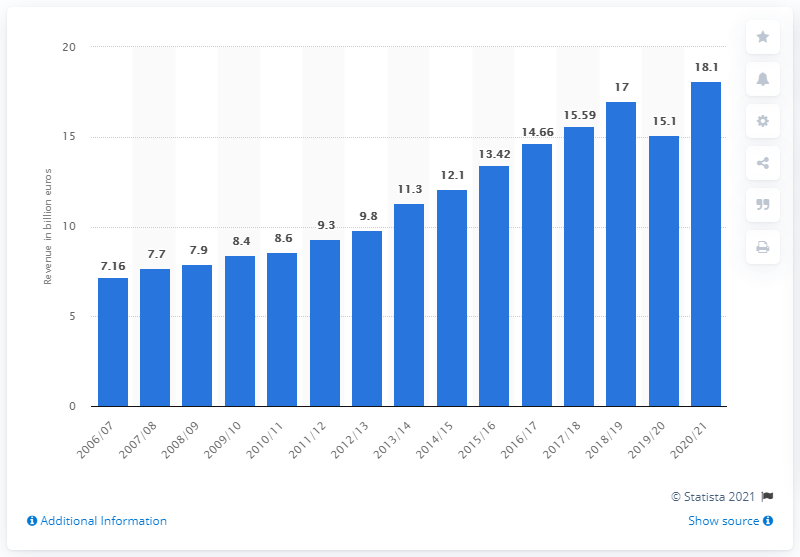Highlight a few significant elements in this photo. In 2018/19, the total revenue of the "Big Five" leagues was approximately 17... 